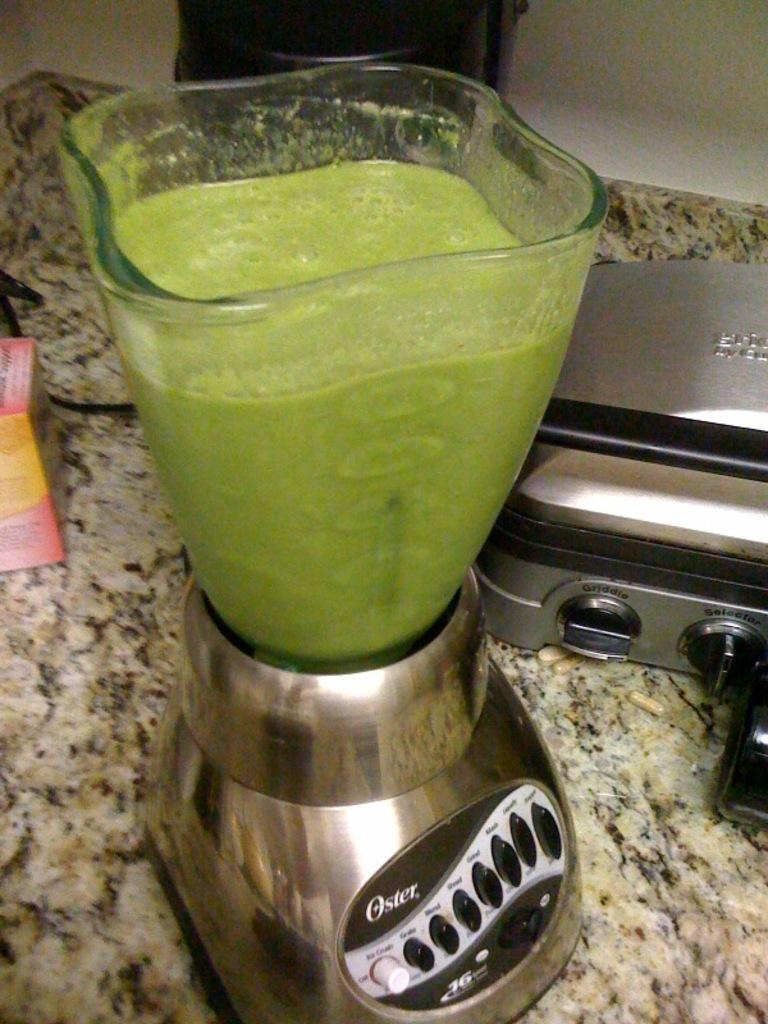<image>
Provide a brief description of the given image. An Oster blender has been used to make a green juice. 